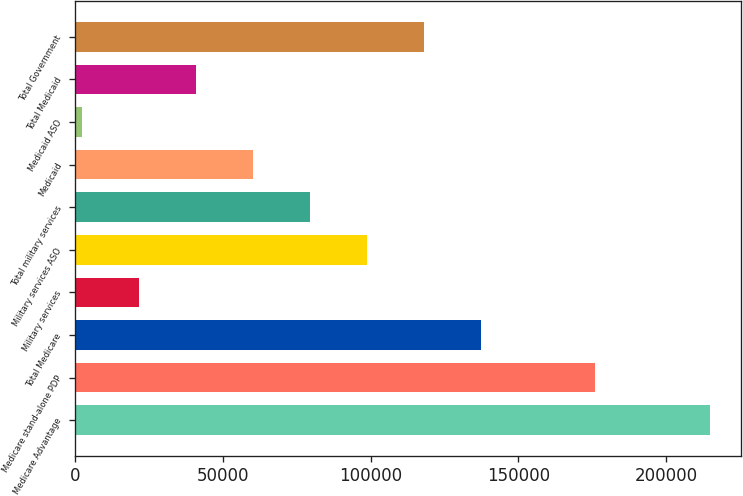Convert chart to OTSL. <chart><loc_0><loc_0><loc_500><loc_500><bar_chart><fcel>Medicare Advantage<fcel>Medicare stand-alone PDP<fcel>Total Medicare<fcel>Military services<fcel>Military services ASO<fcel>Total military services<fcel>Medicaid<fcel>Medicaid ASO<fcel>Total Medicaid<fcel>Total Government<nl><fcel>214720<fcel>176080<fcel>137440<fcel>21520<fcel>98800<fcel>79480<fcel>60160<fcel>2200<fcel>40840<fcel>118120<nl></chart> 